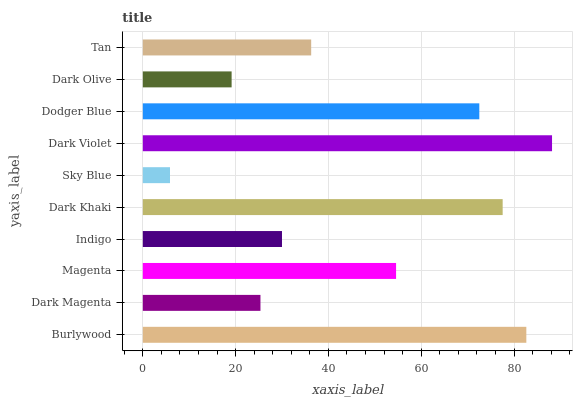Is Sky Blue the minimum?
Answer yes or no. Yes. Is Dark Violet the maximum?
Answer yes or no. Yes. Is Dark Magenta the minimum?
Answer yes or no. No. Is Dark Magenta the maximum?
Answer yes or no. No. Is Burlywood greater than Dark Magenta?
Answer yes or no. Yes. Is Dark Magenta less than Burlywood?
Answer yes or no. Yes. Is Dark Magenta greater than Burlywood?
Answer yes or no. No. Is Burlywood less than Dark Magenta?
Answer yes or no. No. Is Magenta the high median?
Answer yes or no. Yes. Is Tan the low median?
Answer yes or no. Yes. Is Burlywood the high median?
Answer yes or no. No. Is Sky Blue the low median?
Answer yes or no. No. 